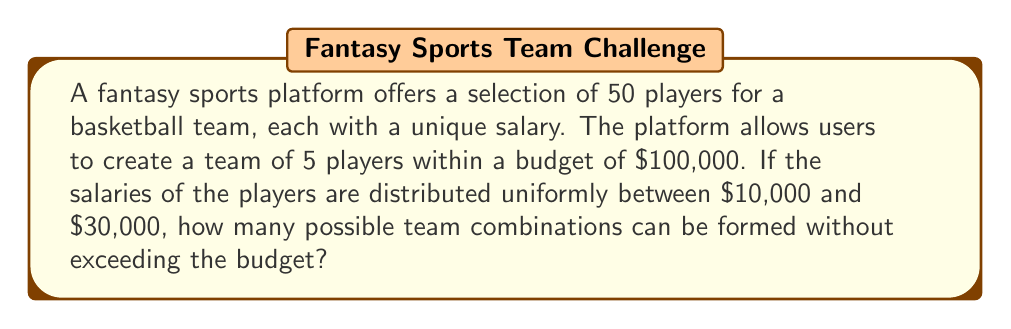Help me with this question. To solve this problem, we need to use combinatorics and probability concepts. Let's break it down step-by-step:

1) First, we need to calculate the expected number of players within our budget. The average salary is:

   $$\text{Average Salary} = \frac{$10,000 + $30,000}{2} = $20,000$$

2) The expected number of players we can afford is:

   $$\text{Expected Players} = \frac{\text{Budget}}{\text{Average Salary}} = \frac{$100,000}{$20,000} = 5$$

3) However, this is just an average. We need to account for the fact that some combinations will exceed the budget. Let's estimate the probability of a random 5-player selection being within budget.

4) The sum of 5 uniformly distributed random variables between 10,000 and 30,000 follows an approximately normal distribution with:

   $$\mu = 5 \cdot 20,000 = 100,000$$
   $$\sigma^2 = 5 \cdot \frac{(30,000 - 10,000)^2}{12} = 16,666,666.67$$
   $$\sigma \approx 4,082.48$$

5) The probability that this sum is less than or equal to 100,000 is:

   $$P(X \leq 100,000) = P(Z \leq 0) = 0.5$$

   Where Z is the standard normal variable.

6) Now, the total number of ways to select 5 players out of 50 is:

   $$\binom{50}{5} = 2,118,760$$

7) Therefore, the estimated number of valid combinations is:

   $$2,118,760 \cdot 0.5 = 1,059,380$$

This is an estimate based on probabilistic reasoning. The actual number may vary slightly due to the discrete nature of the problem and the approximations used.
Answer: Approximately 1,059,380 possible team combinations 